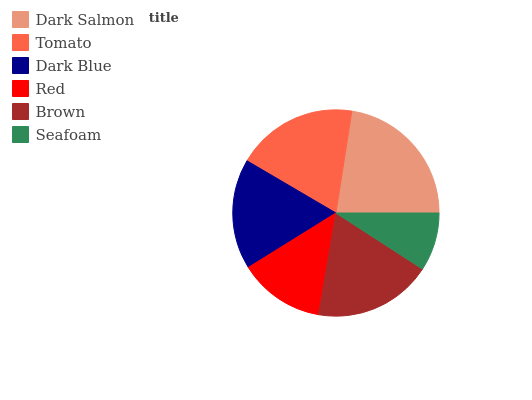Is Seafoam the minimum?
Answer yes or no. Yes. Is Dark Salmon the maximum?
Answer yes or no. Yes. Is Tomato the minimum?
Answer yes or no. No. Is Tomato the maximum?
Answer yes or no. No. Is Dark Salmon greater than Tomato?
Answer yes or no. Yes. Is Tomato less than Dark Salmon?
Answer yes or no. Yes. Is Tomato greater than Dark Salmon?
Answer yes or no. No. Is Dark Salmon less than Tomato?
Answer yes or no. No. Is Brown the high median?
Answer yes or no. Yes. Is Dark Blue the low median?
Answer yes or no. Yes. Is Seafoam the high median?
Answer yes or no. No. Is Tomato the low median?
Answer yes or no. No. 